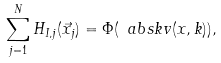<formula> <loc_0><loc_0><loc_500><loc_500>\sum _ { j = 1 } ^ { N } H _ { I , j } ( \vec { x } _ { j } ) = \Phi ( \ a b s { k } v ( x , k ) ) ,</formula> 